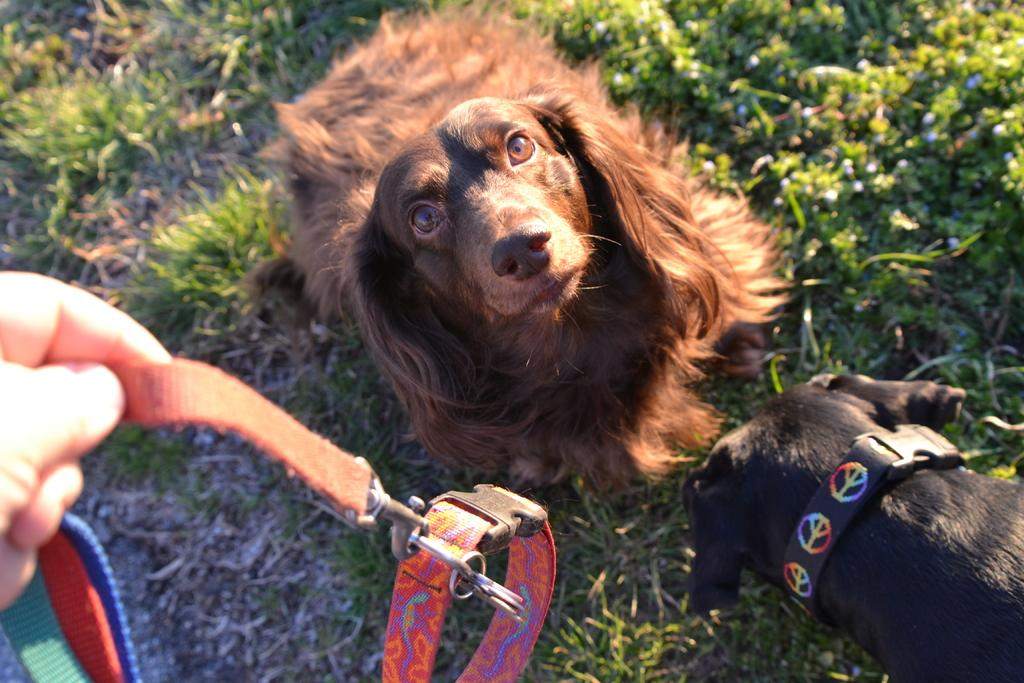How many dogs are in the image? There are two dogs in the image. What is the surface the dogs are on? The dogs are on the grass. What is the position of one of the dogs? One dog is looking upwards. What can be seen on the left side of the image? There is a person's hand holding a belt on the left side of the image. What color is the wool that the fairies are spinning in the image? There are no fairies or wool present in the image. 